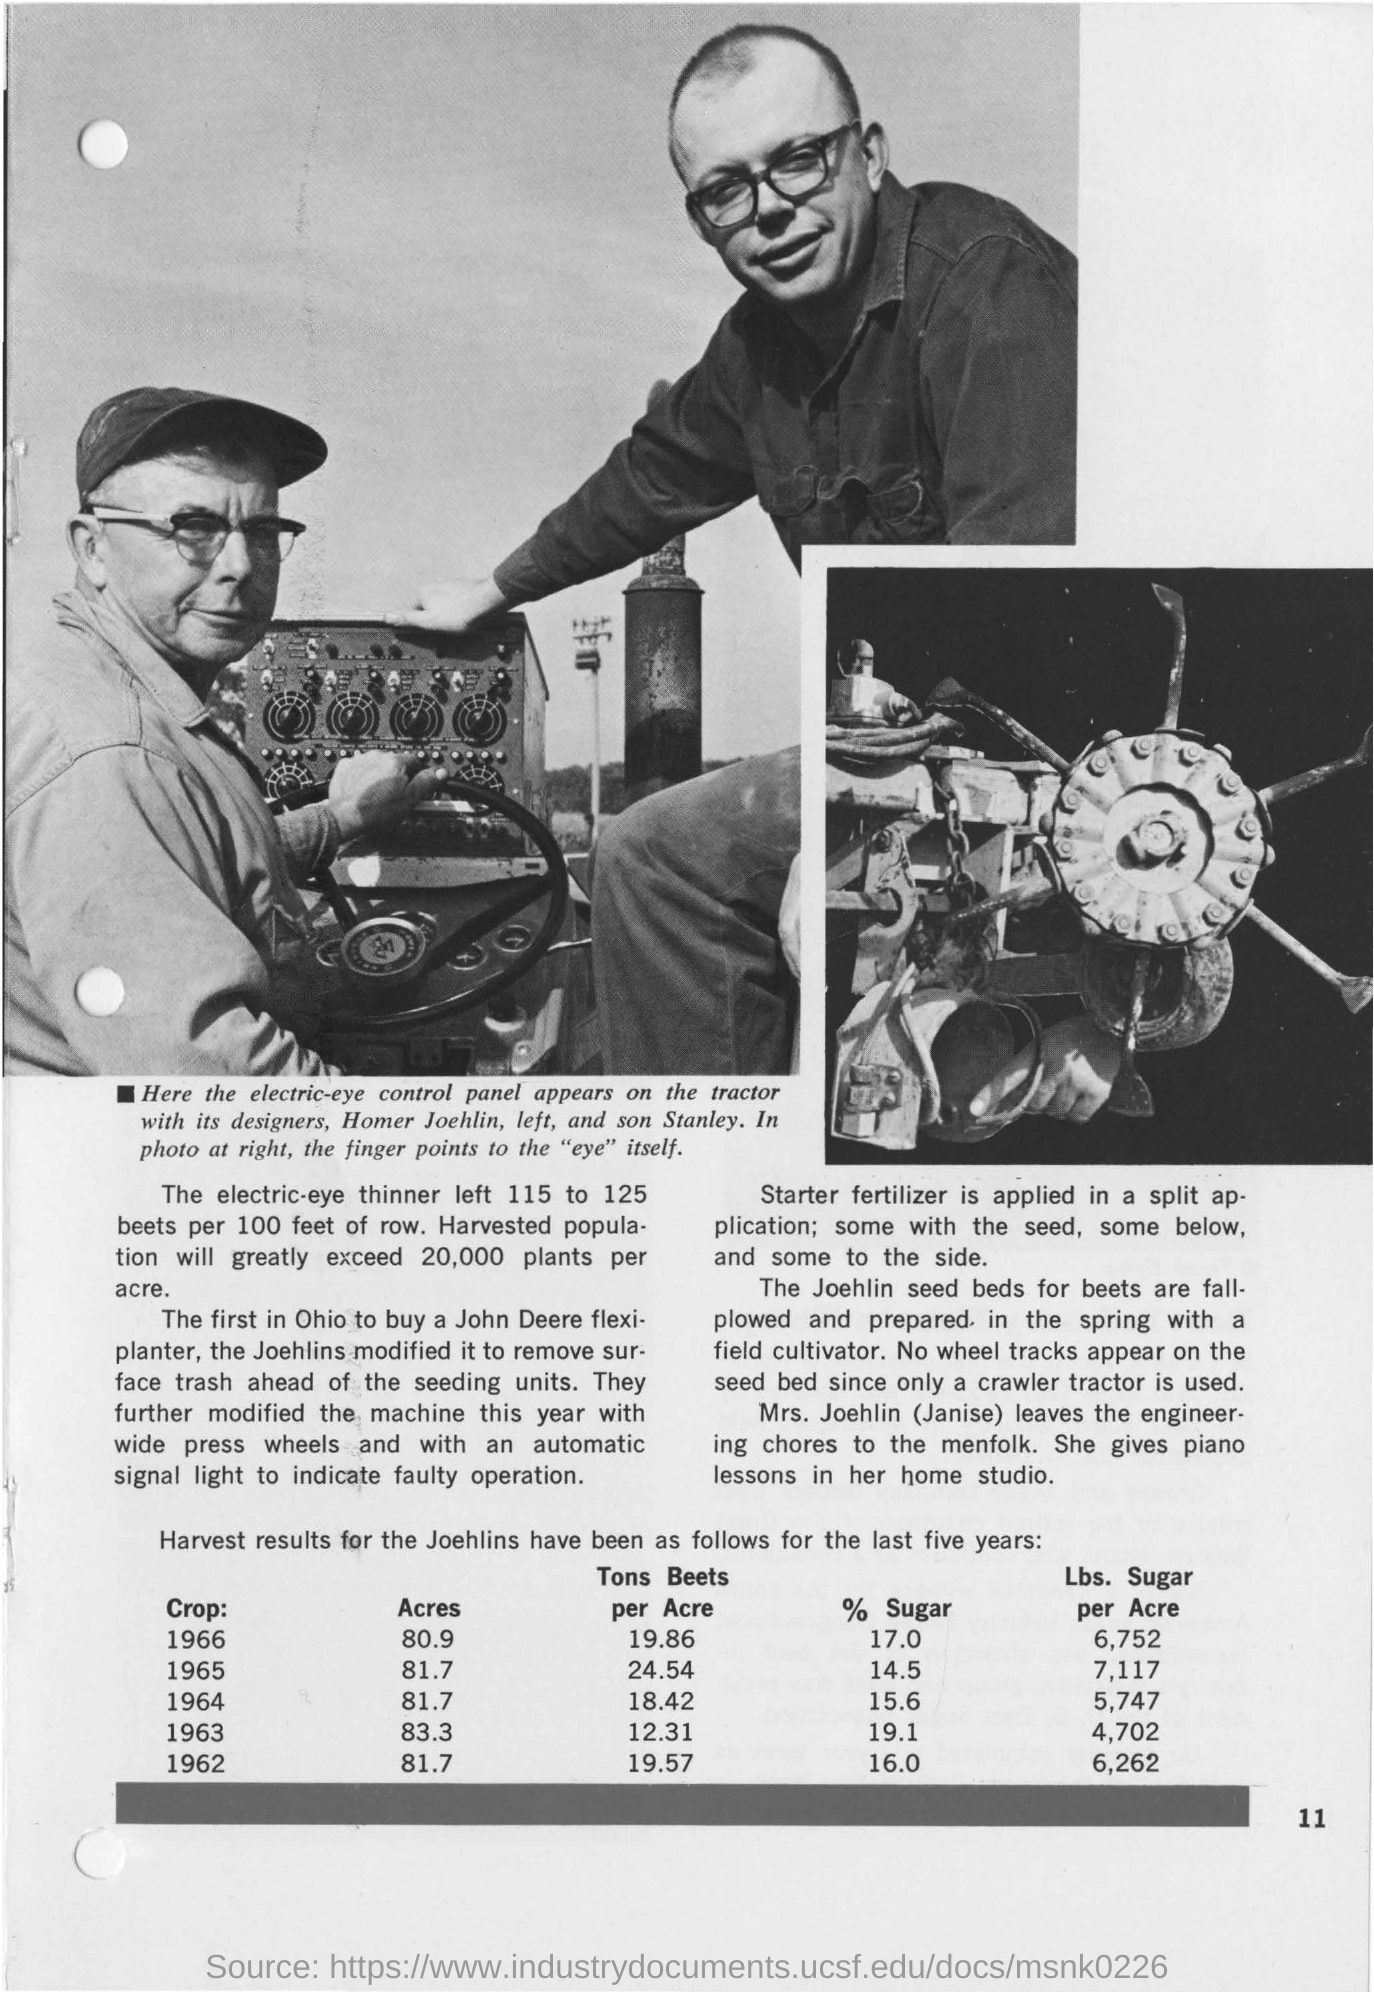Outline some significant characteristics in this image. Which year had the lowest "acres" value? 1966 had the lowest value of acres. Of the years between 1960 and 1969, which one had the highest number of acres? The sugar content of the liquor was 14.5%, which was the lowest value among the samples tested. The value for the crop in 1966 was the highest among all the years mentioned. 